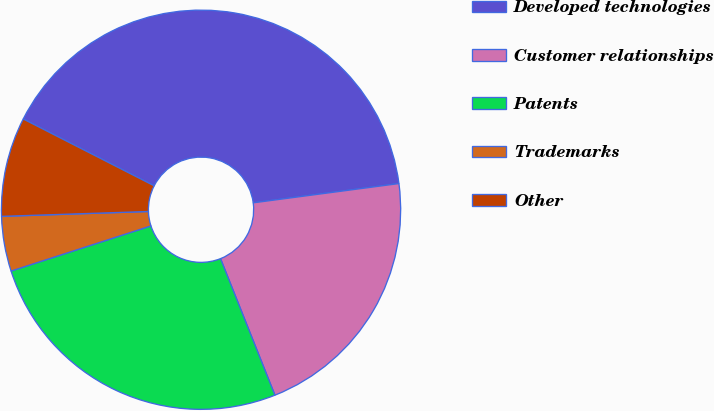Convert chart. <chart><loc_0><loc_0><loc_500><loc_500><pie_chart><fcel>Developed technologies<fcel>Customer relationships<fcel>Patents<fcel>Trademarks<fcel>Other<nl><fcel>40.4%<fcel>21.06%<fcel>26.07%<fcel>4.44%<fcel>8.04%<nl></chart> 